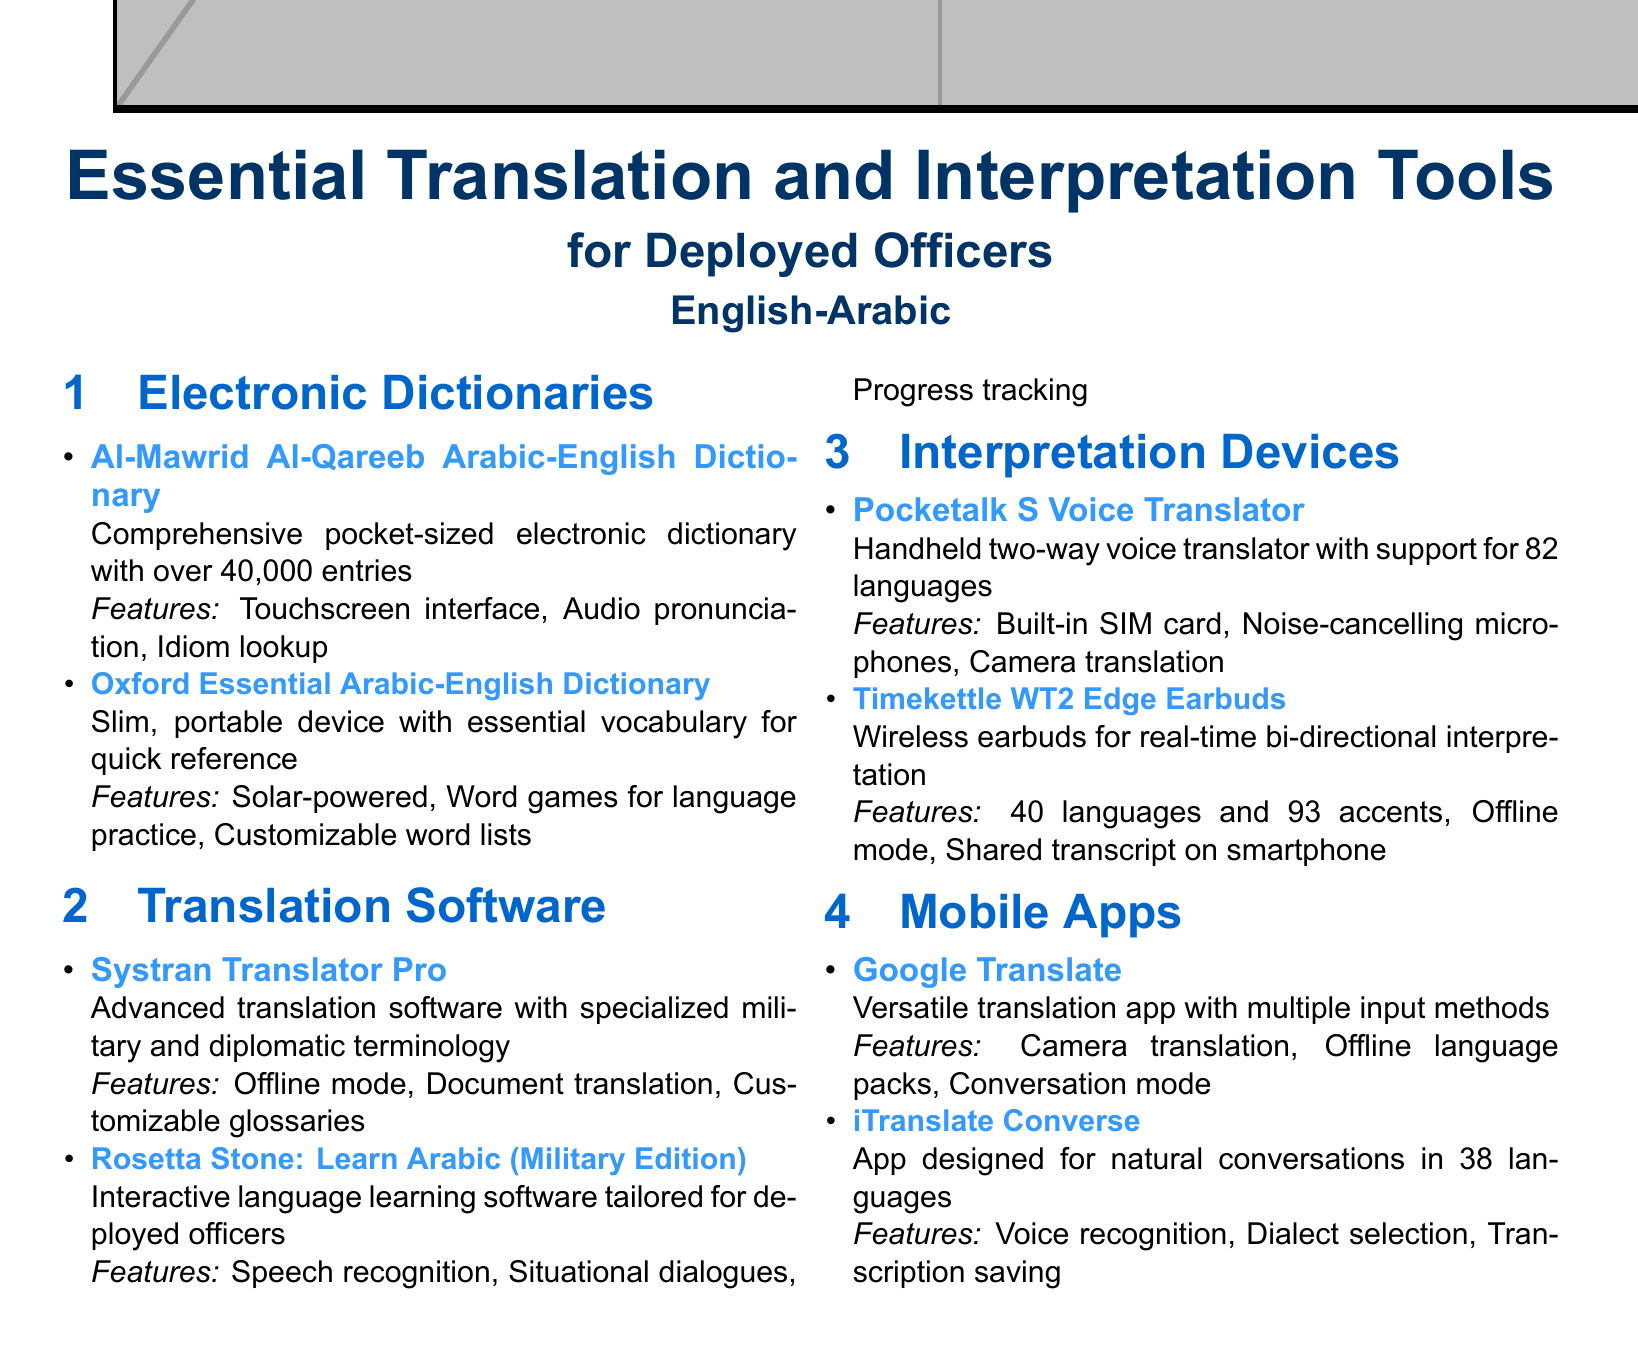what is the main language pair featured in the catalog? The catalog focuses on translation and interpretation tools specifically for the English-Arabic language pair.
Answer: English-Arabic how many entries does the Al-Mawrid Al-Qareeb Arabic-English Dictionary have? The document states that the Al-Mawrid Al-Qareeb Arabic-English Dictionary has over 40,000 entries.
Answer: over 40,000 entries which electronic dictionary is described as solar-powered? The Oxford Essential Arabic-English Dictionary is noted for its solar-powered feature.
Answer: Oxford Essential Arabic-English Dictionary what kind of software is Systran Translator Pro? Systran Translator Pro is classified as advanced translation software with specialized military and diplomatic terminology.
Answer: advanced translation software how many languages does the Pocketalk S Voice Translator support? The Pocketalk S Voice Translator has support for 82 languages.
Answer: 82 languages what is a unique feature of Timekettle WT2 Edge Earbuds? The Timekettle WT2 Edge Earbuds feature real-time bi-directional interpretation.
Answer: real-time bi-directional interpretation which mobile app includes camera translation? Google Translate includes the camera translation feature.
Answer: Google Translate what type of device is the Rosetta Stone: Learn Arabic (Military Edition)? The Rosetta Stone: Learn Arabic (Military Edition) is identified as interactive language learning software.
Answer: interactive language learning software what is a characteristic of iTranslate Converse? iTranslate Converse is designed for natural conversations in 38 languages.
Answer: designed for natural conversations in 38 languages 